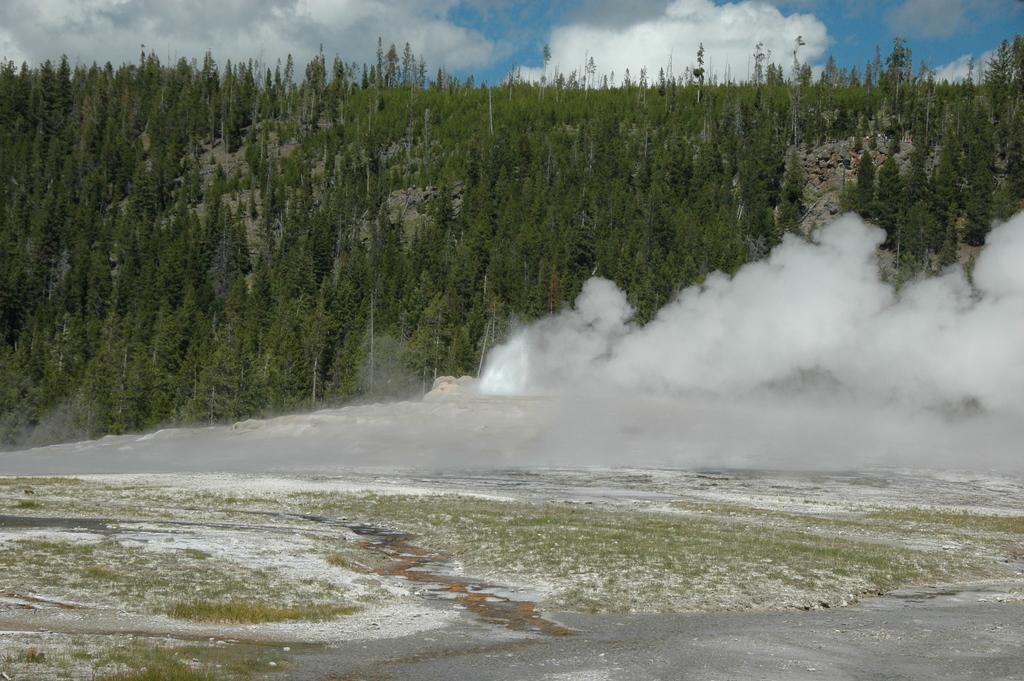Describe this image in one or two sentences. In this image I can see the ground, some white colored thing on the ground and the smoke which is white in color. In the background I can see few trees and the sky. 